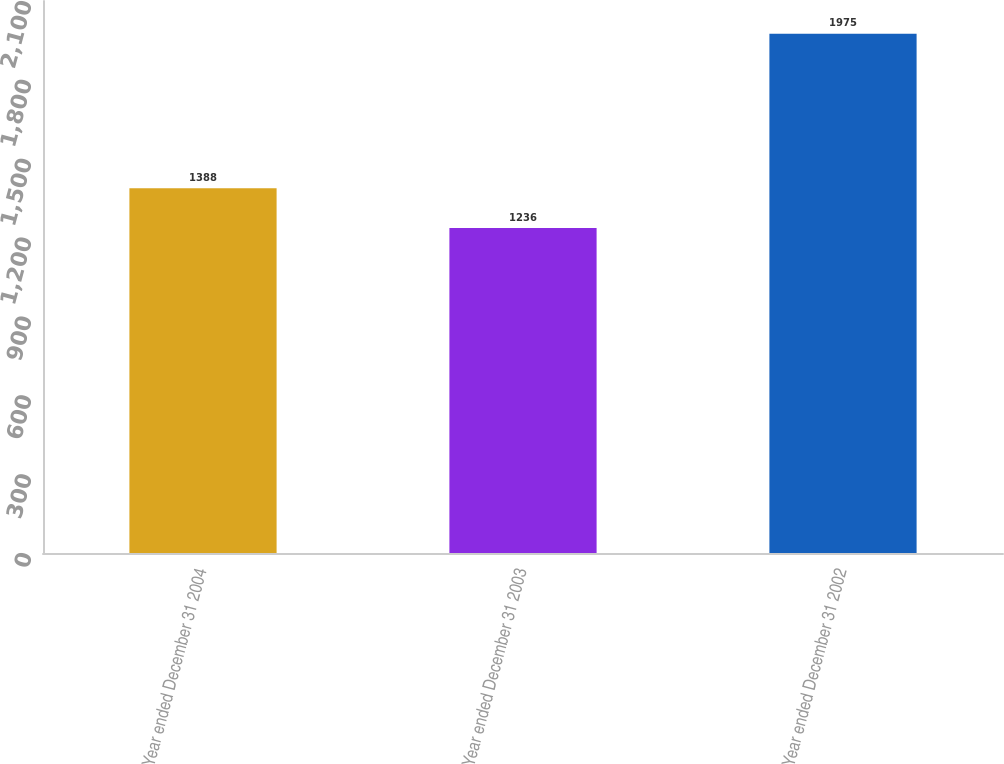<chart> <loc_0><loc_0><loc_500><loc_500><bar_chart><fcel>Year ended December 31 2004<fcel>Year ended December 31 2003<fcel>Year ended December 31 2002<nl><fcel>1388<fcel>1236<fcel>1975<nl></chart> 